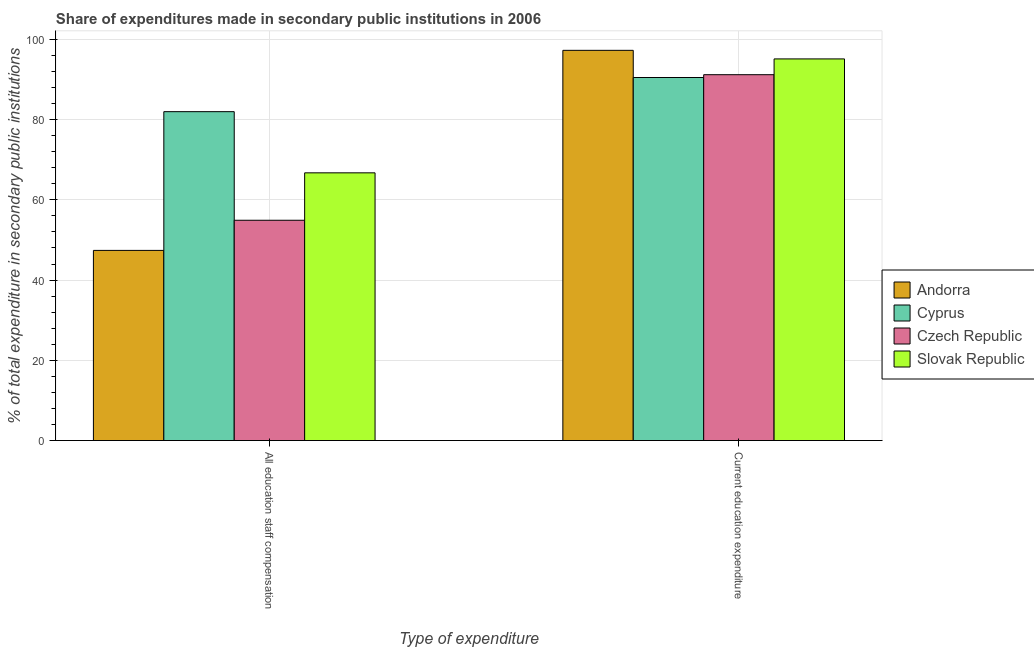How many groups of bars are there?
Provide a succinct answer. 2. How many bars are there on the 2nd tick from the right?
Make the answer very short. 4. What is the label of the 1st group of bars from the left?
Your answer should be compact. All education staff compensation. What is the expenditure in education in Cyprus?
Offer a very short reply. 90.49. Across all countries, what is the maximum expenditure in education?
Your answer should be compact. 97.26. Across all countries, what is the minimum expenditure in staff compensation?
Provide a short and direct response. 47.4. In which country was the expenditure in staff compensation maximum?
Your answer should be very brief. Cyprus. In which country was the expenditure in staff compensation minimum?
Your response must be concise. Andorra. What is the total expenditure in staff compensation in the graph?
Give a very brief answer. 251.01. What is the difference between the expenditure in education in Andorra and that in Cyprus?
Make the answer very short. 6.77. What is the difference between the expenditure in education in Andorra and the expenditure in staff compensation in Slovak Republic?
Offer a terse response. 30.53. What is the average expenditure in education per country?
Make the answer very short. 93.51. What is the difference between the expenditure in education and expenditure in staff compensation in Slovak Republic?
Give a very brief answer. 28.39. What is the ratio of the expenditure in staff compensation in Slovak Republic to that in Czech Republic?
Your answer should be very brief. 1.22. Is the expenditure in staff compensation in Czech Republic less than that in Slovak Republic?
Keep it short and to the point. Yes. In how many countries, is the expenditure in staff compensation greater than the average expenditure in staff compensation taken over all countries?
Keep it short and to the point. 2. What does the 1st bar from the left in Current education expenditure represents?
Offer a terse response. Andorra. What does the 3rd bar from the right in Current education expenditure represents?
Your answer should be very brief. Cyprus. Are all the bars in the graph horizontal?
Your response must be concise. No. Are the values on the major ticks of Y-axis written in scientific E-notation?
Give a very brief answer. No. Does the graph contain any zero values?
Your answer should be very brief. No. How are the legend labels stacked?
Provide a succinct answer. Vertical. What is the title of the graph?
Give a very brief answer. Share of expenditures made in secondary public institutions in 2006. What is the label or title of the X-axis?
Provide a short and direct response. Type of expenditure. What is the label or title of the Y-axis?
Ensure brevity in your answer.  % of total expenditure in secondary public institutions. What is the % of total expenditure in secondary public institutions of Andorra in All education staff compensation?
Ensure brevity in your answer.  47.4. What is the % of total expenditure in secondary public institutions of Cyprus in All education staff compensation?
Offer a terse response. 81.98. What is the % of total expenditure in secondary public institutions in Czech Republic in All education staff compensation?
Keep it short and to the point. 54.91. What is the % of total expenditure in secondary public institutions in Slovak Republic in All education staff compensation?
Give a very brief answer. 66.73. What is the % of total expenditure in secondary public institutions of Andorra in Current education expenditure?
Provide a short and direct response. 97.26. What is the % of total expenditure in secondary public institutions in Cyprus in Current education expenditure?
Ensure brevity in your answer.  90.49. What is the % of total expenditure in secondary public institutions of Czech Republic in Current education expenditure?
Offer a terse response. 91.19. What is the % of total expenditure in secondary public institutions in Slovak Republic in Current education expenditure?
Provide a succinct answer. 95.12. Across all Type of expenditure, what is the maximum % of total expenditure in secondary public institutions in Andorra?
Provide a succinct answer. 97.26. Across all Type of expenditure, what is the maximum % of total expenditure in secondary public institutions in Cyprus?
Your response must be concise. 90.49. Across all Type of expenditure, what is the maximum % of total expenditure in secondary public institutions in Czech Republic?
Make the answer very short. 91.19. Across all Type of expenditure, what is the maximum % of total expenditure in secondary public institutions in Slovak Republic?
Provide a succinct answer. 95.12. Across all Type of expenditure, what is the minimum % of total expenditure in secondary public institutions in Andorra?
Offer a terse response. 47.4. Across all Type of expenditure, what is the minimum % of total expenditure in secondary public institutions in Cyprus?
Keep it short and to the point. 81.98. Across all Type of expenditure, what is the minimum % of total expenditure in secondary public institutions of Czech Republic?
Offer a very short reply. 54.91. Across all Type of expenditure, what is the minimum % of total expenditure in secondary public institutions of Slovak Republic?
Offer a very short reply. 66.73. What is the total % of total expenditure in secondary public institutions of Andorra in the graph?
Your answer should be compact. 144.66. What is the total % of total expenditure in secondary public institutions of Cyprus in the graph?
Provide a short and direct response. 172.46. What is the total % of total expenditure in secondary public institutions of Czech Republic in the graph?
Make the answer very short. 146.1. What is the total % of total expenditure in secondary public institutions of Slovak Republic in the graph?
Ensure brevity in your answer.  161.85. What is the difference between the % of total expenditure in secondary public institutions in Andorra in All education staff compensation and that in Current education expenditure?
Provide a short and direct response. -49.86. What is the difference between the % of total expenditure in secondary public institutions in Cyprus in All education staff compensation and that in Current education expenditure?
Make the answer very short. -8.51. What is the difference between the % of total expenditure in secondary public institutions in Czech Republic in All education staff compensation and that in Current education expenditure?
Keep it short and to the point. -36.28. What is the difference between the % of total expenditure in secondary public institutions in Slovak Republic in All education staff compensation and that in Current education expenditure?
Your answer should be very brief. -28.39. What is the difference between the % of total expenditure in secondary public institutions of Andorra in All education staff compensation and the % of total expenditure in secondary public institutions of Cyprus in Current education expenditure?
Ensure brevity in your answer.  -43.09. What is the difference between the % of total expenditure in secondary public institutions of Andorra in All education staff compensation and the % of total expenditure in secondary public institutions of Czech Republic in Current education expenditure?
Ensure brevity in your answer.  -43.79. What is the difference between the % of total expenditure in secondary public institutions of Andorra in All education staff compensation and the % of total expenditure in secondary public institutions of Slovak Republic in Current education expenditure?
Keep it short and to the point. -47.72. What is the difference between the % of total expenditure in secondary public institutions of Cyprus in All education staff compensation and the % of total expenditure in secondary public institutions of Czech Republic in Current education expenditure?
Keep it short and to the point. -9.21. What is the difference between the % of total expenditure in secondary public institutions of Cyprus in All education staff compensation and the % of total expenditure in secondary public institutions of Slovak Republic in Current education expenditure?
Your answer should be compact. -13.15. What is the difference between the % of total expenditure in secondary public institutions of Czech Republic in All education staff compensation and the % of total expenditure in secondary public institutions of Slovak Republic in Current education expenditure?
Your answer should be compact. -40.21. What is the average % of total expenditure in secondary public institutions in Andorra per Type of expenditure?
Your answer should be very brief. 72.33. What is the average % of total expenditure in secondary public institutions in Cyprus per Type of expenditure?
Make the answer very short. 86.23. What is the average % of total expenditure in secondary public institutions of Czech Republic per Type of expenditure?
Your answer should be compact. 73.05. What is the average % of total expenditure in secondary public institutions of Slovak Republic per Type of expenditure?
Your answer should be compact. 80.93. What is the difference between the % of total expenditure in secondary public institutions in Andorra and % of total expenditure in secondary public institutions in Cyprus in All education staff compensation?
Keep it short and to the point. -34.58. What is the difference between the % of total expenditure in secondary public institutions in Andorra and % of total expenditure in secondary public institutions in Czech Republic in All education staff compensation?
Offer a very short reply. -7.51. What is the difference between the % of total expenditure in secondary public institutions of Andorra and % of total expenditure in secondary public institutions of Slovak Republic in All education staff compensation?
Provide a short and direct response. -19.33. What is the difference between the % of total expenditure in secondary public institutions of Cyprus and % of total expenditure in secondary public institutions of Czech Republic in All education staff compensation?
Provide a succinct answer. 27.07. What is the difference between the % of total expenditure in secondary public institutions in Cyprus and % of total expenditure in secondary public institutions in Slovak Republic in All education staff compensation?
Offer a terse response. 15.25. What is the difference between the % of total expenditure in secondary public institutions in Czech Republic and % of total expenditure in secondary public institutions in Slovak Republic in All education staff compensation?
Give a very brief answer. -11.82. What is the difference between the % of total expenditure in secondary public institutions of Andorra and % of total expenditure in secondary public institutions of Cyprus in Current education expenditure?
Offer a very short reply. 6.77. What is the difference between the % of total expenditure in secondary public institutions in Andorra and % of total expenditure in secondary public institutions in Czech Republic in Current education expenditure?
Your answer should be compact. 6.07. What is the difference between the % of total expenditure in secondary public institutions of Andorra and % of total expenditure in secondary public institutions of Slovak Republic in Current education expenditure?
Your answer should be very brief. 2.14. What is the difference between the % of total expenditure in secondary public institutions in Cyprus and % of total expenditure in secondary public institutions in Czech Republic in Current education expenditure?
Your answer should be compact. -0.7. What is the difference between the % of total expenditure in secondary public institutions in Cyprus and % of total expenditure in secondary public institutions in Slovak Republic in Current education expenditure?
Keep it short and to the point. -4.64. What is the difference between the % of total expenditure in secondary public institutions in Czech Republic and % of total expenditure in secondary public institutions in Slovak Republic in Current education expenditure?
Offer a very short reply. -3.93. What is the ratio of the % of total expenditure in secondary public institutions in Andorra in All education staff compensation to that in Current education expenditure?
Offer a terse response. 0.49. What is the ratio of the % of total expenditure in secondary public institutions in Cyprus in All education staff compensation to that in Current education expenditure?
Your response must be concise. 0.91. What is the ratio of the % of total expenditure in secondary public institutions in Czech Republic in All education staff compensation to that in Current education expenditure?
Provide a succinct answer. 0.6. What is the ratio of the % of total expenditure in secondary public institutions of Slovak Republic in All education staff compensation to that in Current education expenditure?
Offer a terse response. 0.7. What is the difference between the highest and the second highest % of total expenditure in secondary public institutions of Andorra?
Ensure brevity in your answer.  49.86. What is the difference between the highest and the second highest % of total expenditure in secondary public institutions in Cyprus?
Make the answer very short. 8.51. What is the difference between the highest and the second highest % of total expenditure in secondary public institutions of Czech Republic?
Your answer should be very brief. 36.28. What is the difference between the highest and the second highest % of total expenditure in secondary public institutions in Slovak Republic?
Offer a very short reply. 28.39. What is the difference between the highest and the lowest % of total expenditure in secondary public institutions in Andorra?
Keep it short and to the point. 49.86. What is the difference between the highest and the lowest % of total expenditure in secondary public institutions in Cyprus?
Provide a short and direct response. 8.51. What is the difference between the highest and the lowest % of total expenditure in secondary public institutions in Czech Republic?
Offer a terse response. 36.28. What is the difference between the highest and the lowest % of total expenditure in secondary public institutions in Slovak Republic?
Give a very brief answer. 28.39. 